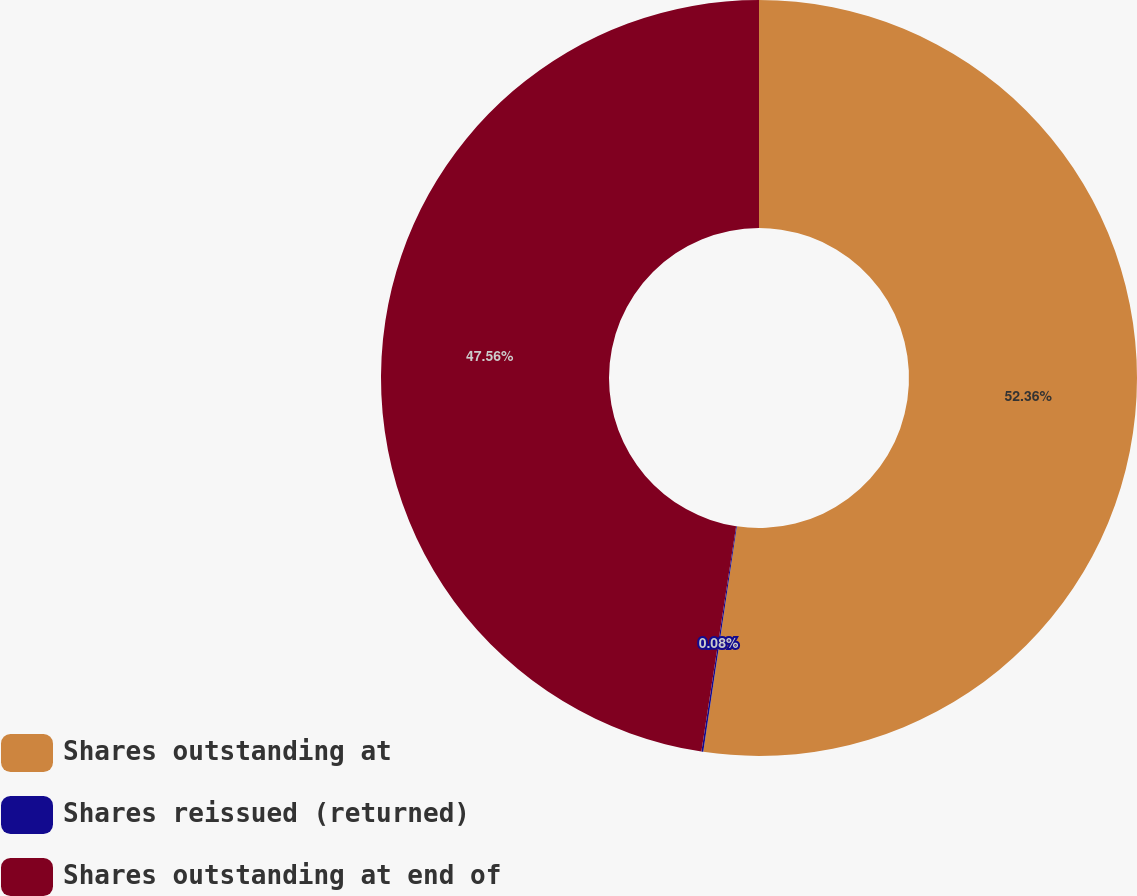Convert chart. <chart><loc_0><loc_0><loc_500><loc_500><pie_chart><fcel>Shares outstanding at<fcel>Shares reissued (returned)<fcel>Shares outstanding at end of<nl><fcel>52.35%<fcel>0.08%<fcel>47.56%<nl></chart> 